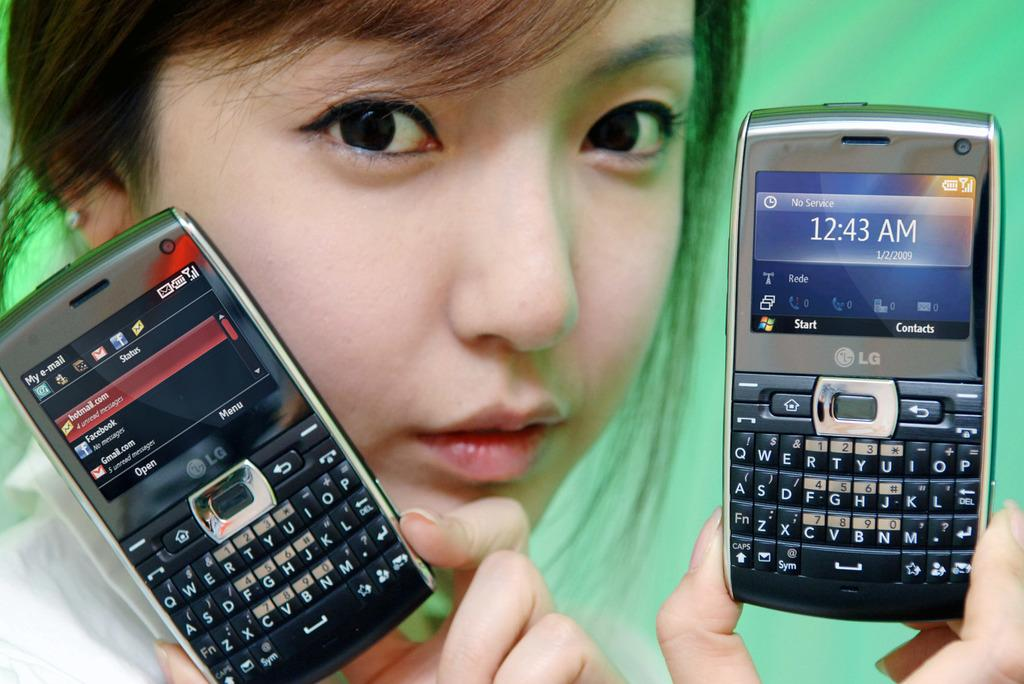Who is the main subject in the image? There is a girl in the image. What is the girl holding in the image? The girl is holding two cell phones. What color can be seen in the background of the image? There is green color in the background of the image. What type of hen can be seen in the image? There is no hen present in the image. 